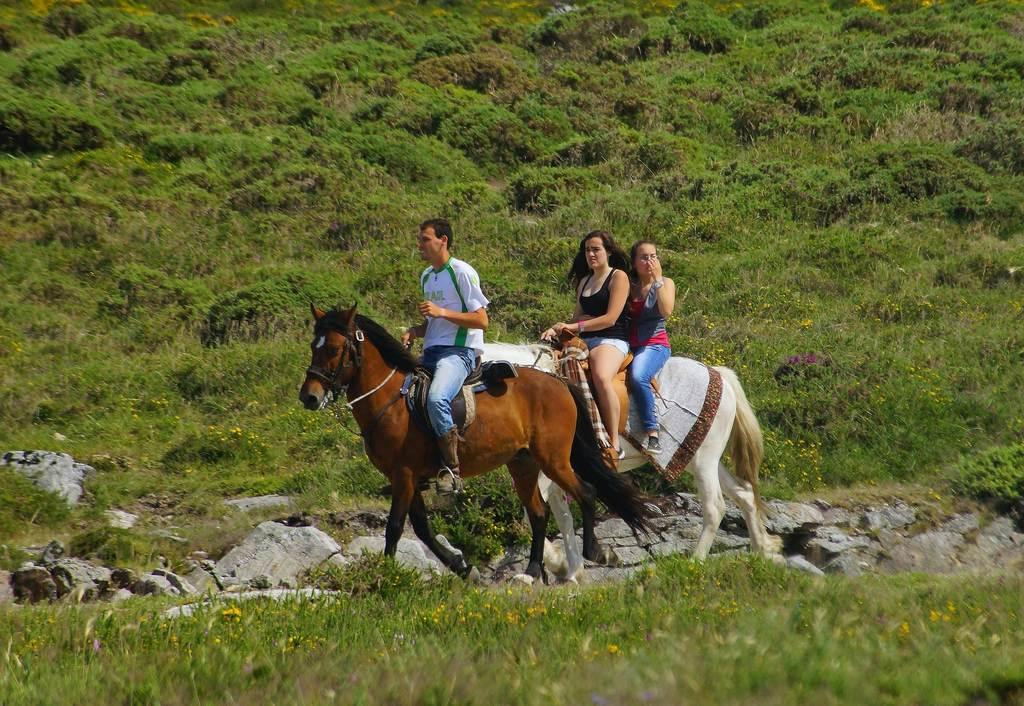What are the people in the image doing? The people in the image are riding on horses. What can be seen in the background of the image? There are plants and grass in the background of the image. Reasoning: Let'g: Let's think step by step in order to produce the conversation. We start by identifying the main action in the image, which is the people riding on horses. Then, we describe the background of the image, mentioning the presence of plants and grass. We avoid yes/no questions and ensure that the language is simple and clear. Absurd Question/Answer: What type of crayon is being used to draw on the horse's back in the image? There is no crayon or drawing on the horse's back in the image. What drug is being administered to the horses in the image? There is no drug or any indication of drug administration in the image. 